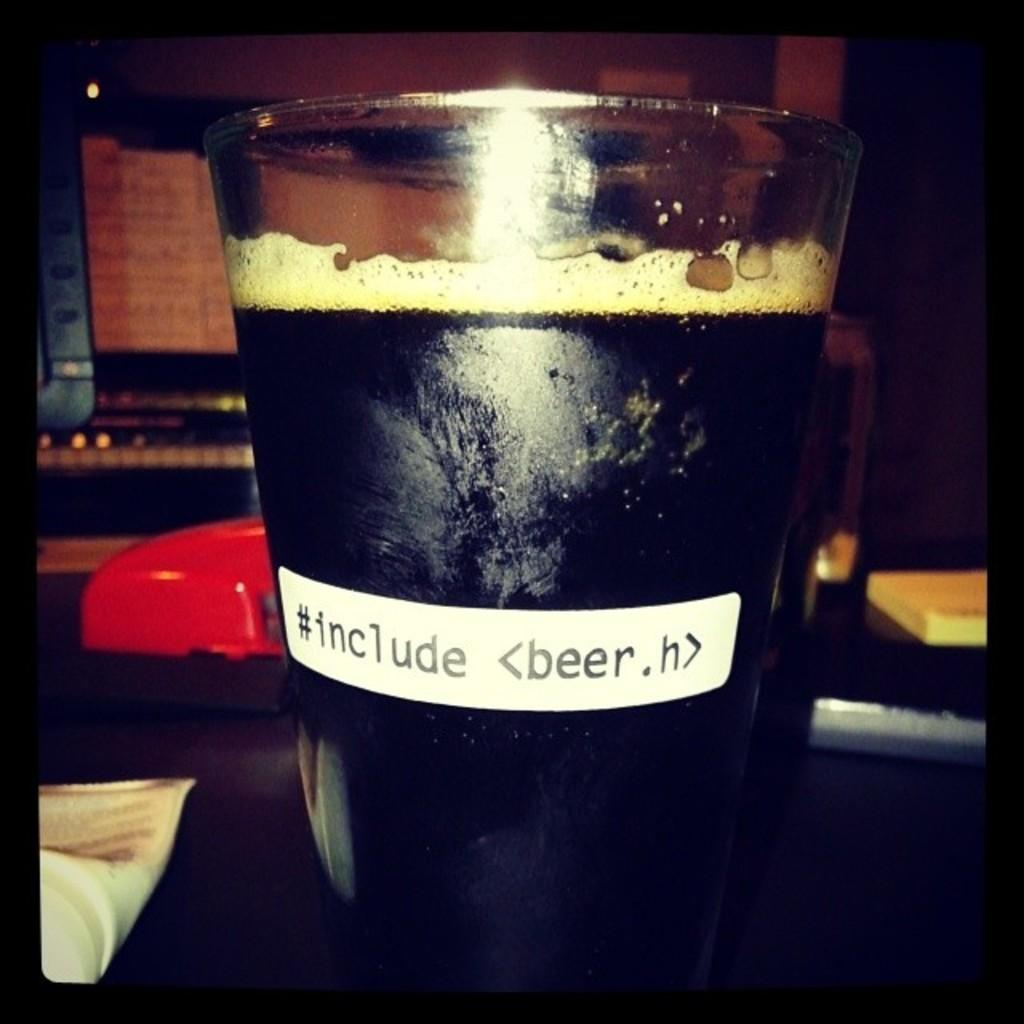<image>
Relay a brief, clear account of the picture shown. a glass that reads Include beer on a bar table 